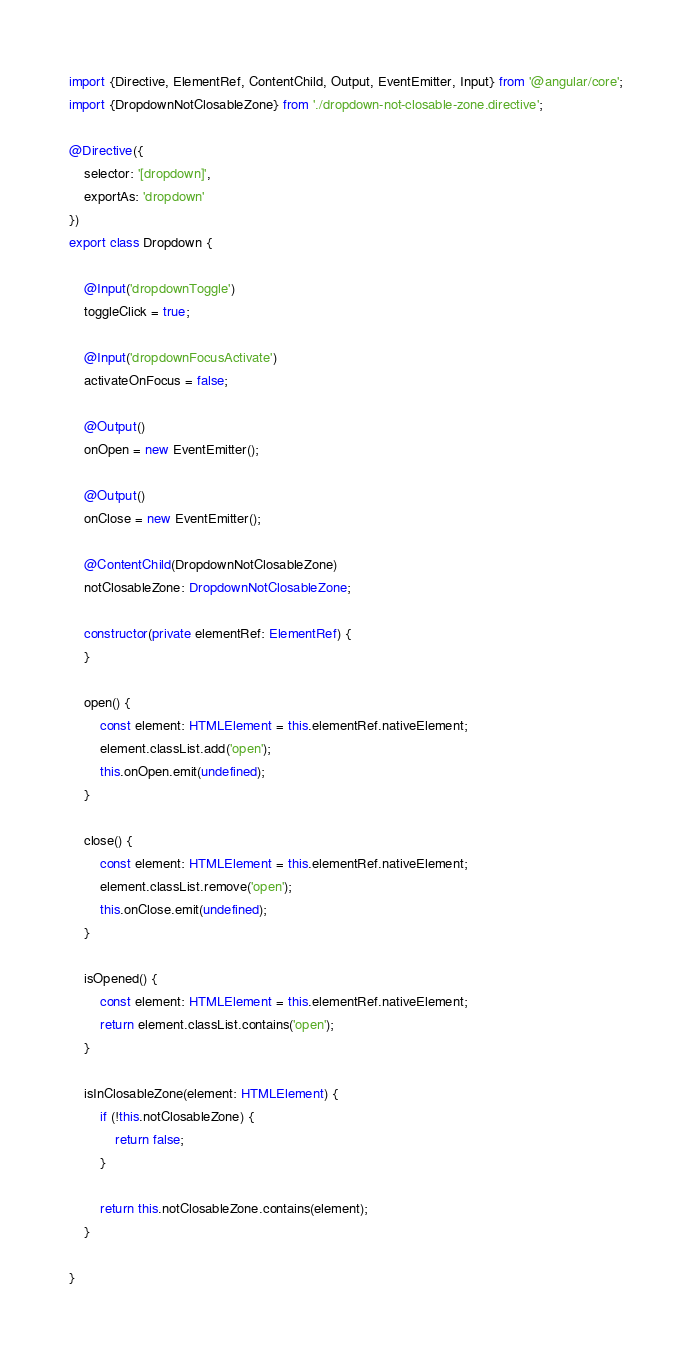<code> <loc_0><loc_0><loc_500><loc_500><_TypeScript_>import {Directive, ElementRef, ContentChild, Output, EventEmitter, Input} from '@angular/core';
import {DropdownNotClosableZone} from './dropdown-not-closable-zone.directive';

@Directive({
    selector: '[dropdown]',
    exportAs: 'dropdown'
})
export class Dropdown {

    @Input('dropdownToggle')
    toggleClick = true;

    @Input('dropdownFocusActivate')
    activateOnFocus = false;

    @Output()
    onOpen = new EventEmitter();

    @Output()
    onClose = new EventEmitter();

    @ContentChild(DropdownNotClosableZone)
    notClosableZone: DropdownNotClosableZone;

    constructor(private elementRef: ElementRef) {
    }

    open() {
        const element: HTMLElement = this.elementRef.nativeElement;
        element.classList.add('open');
        this.onOpen.emit(undefined);
    }

    close() {
        const element: HTMLElement = this.elementRef.nativeElement;
        element.classList.remove('open');
        this.onClose.emit(undefined);
    }

    isOpened() {
        const element: HTMLElement = this.elementRef.nativeElement;
        return element.classList.contains('open');
    }

    isInClosableZone(element: HTMLElement) {
        if (!this.notClosableZone) {
            return false;
        }

        return this.notClosableZone.contains(element);
    }

}
</code> 